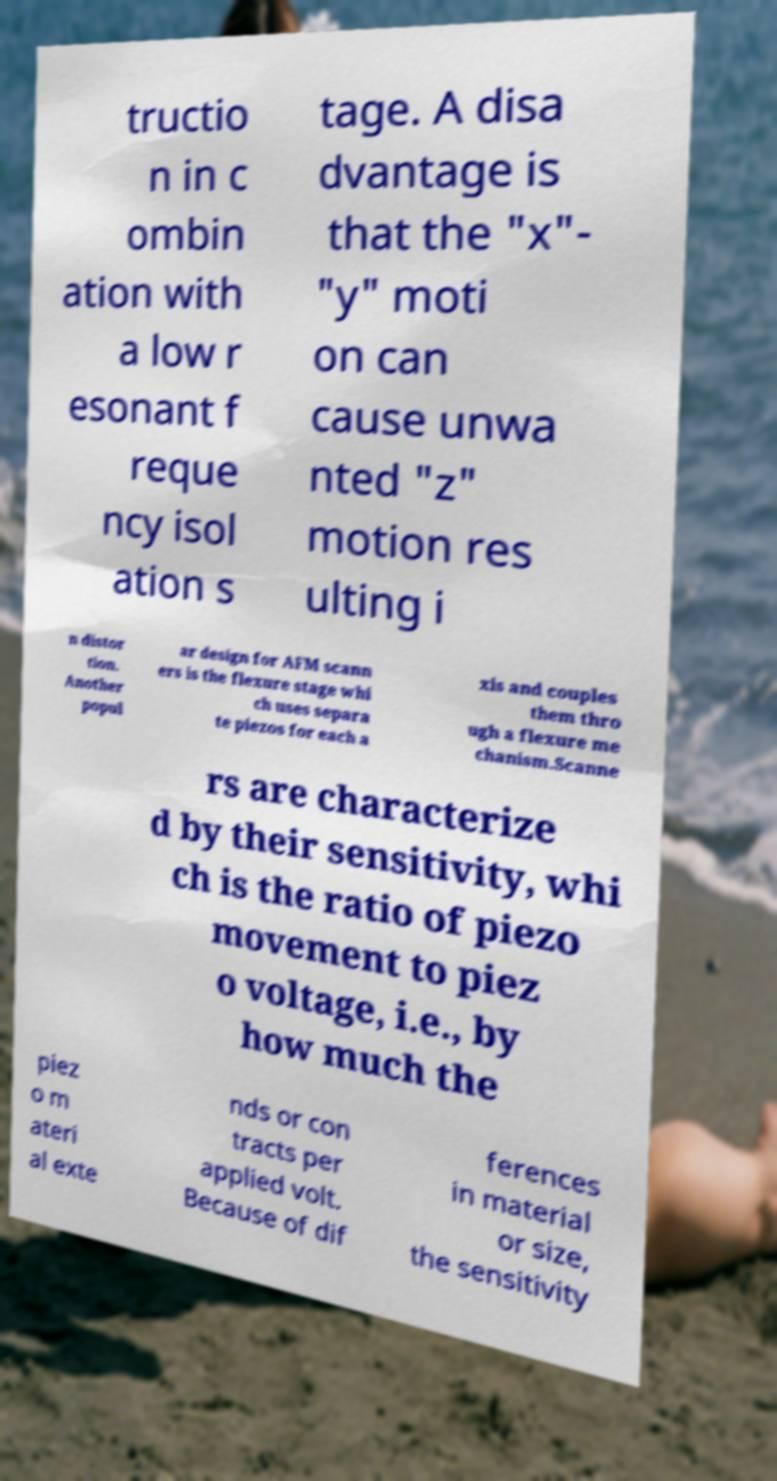Please read and relay the text visible in this image. What does it say? tructio n in c ombin ation with a low r esonant f reque ncy isol ation s tage. A disa dvantage is that the "x"- "y" moti on can cause unwa nted "z" motion res ulting i n distor tion. Another popul ar design for AFM scann ers is the flexure stage whi ch uses separa te piezos for each a xis and couples them thro ugh a flexure me chanism.Scanne rs are characterize d by their sensitivity, whi ch is the ratio of piezo movement to piez o voltage, i.e., by how much the piez o m ateri al exte nds or con tracts per applied volt. Because of dif ferences in material or size, the sensitivity 